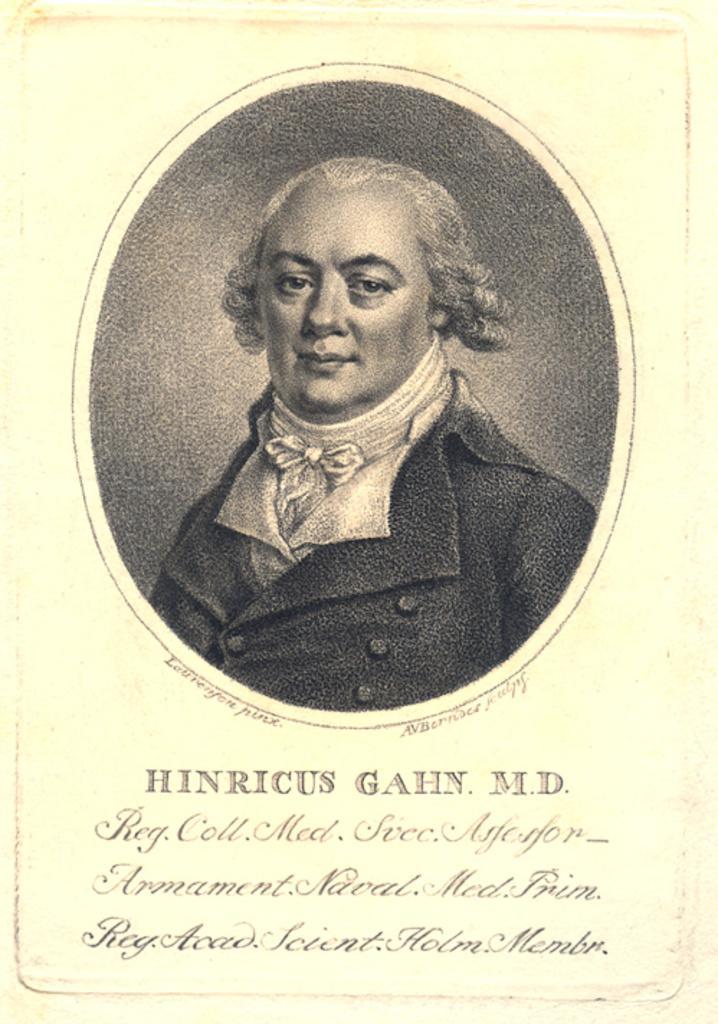Can you describe this image briefly? In this image there is one paper, on the paper there is some text and one person. 